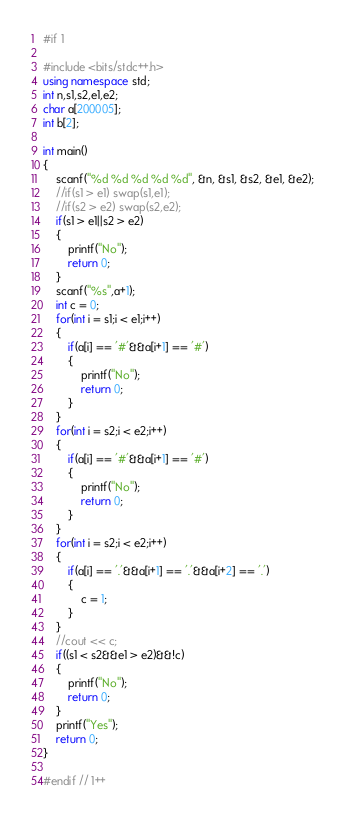<code> <loc_0><loc_0><loc_500><loc_500><_C++_>#if 1

#include <bits/stdc++.h>
using namespace std;
int n,s1,s2,e1,e2;
char a[200005];
int b[2];

int main()
{
    scanf("%d %d %d %d %d", &n, &s1, &s2, &e1, &e2);
    //if(s1 > e1) swap(s1,e1);
    //if(s2 > e2) swap(s2,e2);
    if(s1 > e1||s2 > e2)
    {
        printf("No");
        return 0;
    }
    scanf("%s",a+1);
    int c = 0;
    for(int i = s1;i < e1;i++)
    {
        if(a[i] == '#'&&a[i+1] == '#')
        {
            printf("No");
            return 0;
        }
    }
    for(int i = s2;i < e2;i++)
    {
        if(a[i] == '#'&&a[i+1] == '#')
        {
            printf("No");
            return 0;
        }
    }
    for(int i = s2;i < e2;i++)
    {
        if(a[i] == '.'&&a[i+1] == '.'&&a[i+2] == '.')
        {
            c = 1;
        }
    }
    //cout << c;
    if((s1 < s2&&e1 > e2)&&!c)
    {
        printf("No");
        return 0;
    }
    printf("Yes");
    return 0;
}

#endif // 1++</code> 